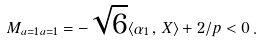Convert formula to latex. <formula><loc_0><loc_0><loc_500><loc_500>M _ { a = 1 \, a = 1 } = - \sqrt { 6 } \langle \alpha _ { 1 } \, , \, X \rangle + 2 / p < 0 \, .</formula> 